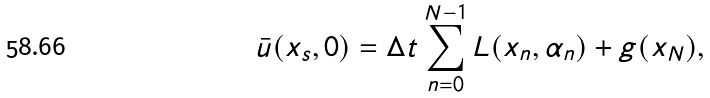<formula> <loc_0><loc_0><loc_500><loc_500>\bar { u } ( x _ { s } , 0 ) = \Delta t \sum _ { n = 0 } ^ { N - 1 } L ( x _ { n } , \alpha _ { n } ) + g ( x _ { N } ) ,</formula> 